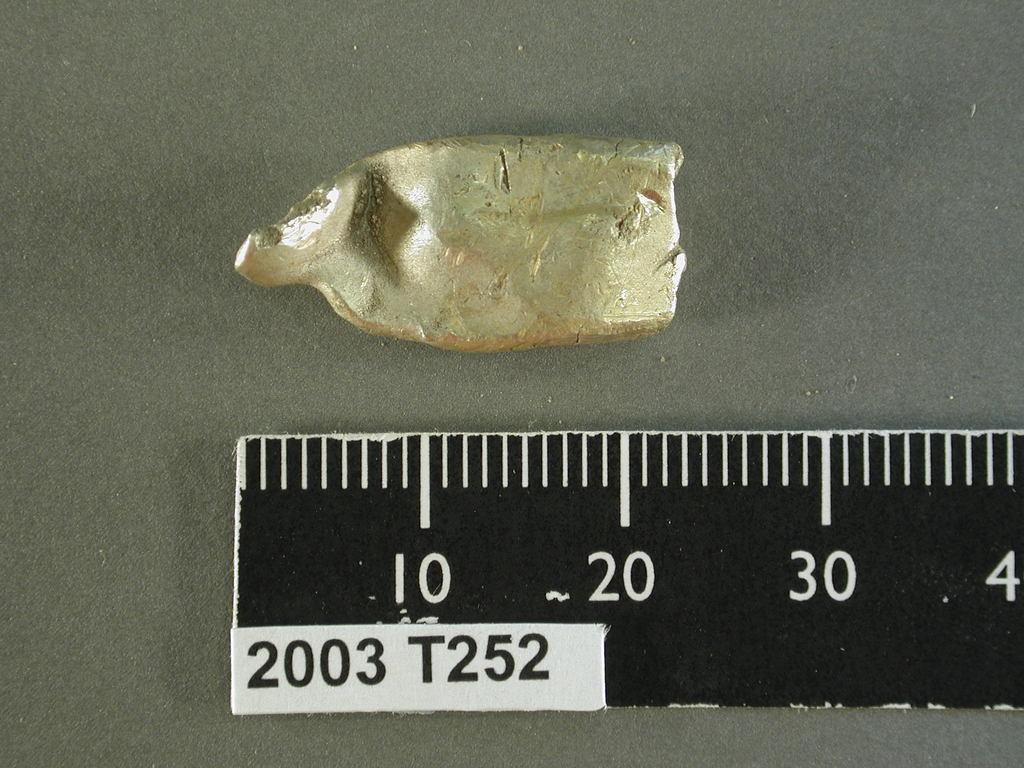<image>
Share a concise interpretation of the image provided. Ruer 2003 T252 is laid out to measure a piece of putty. 